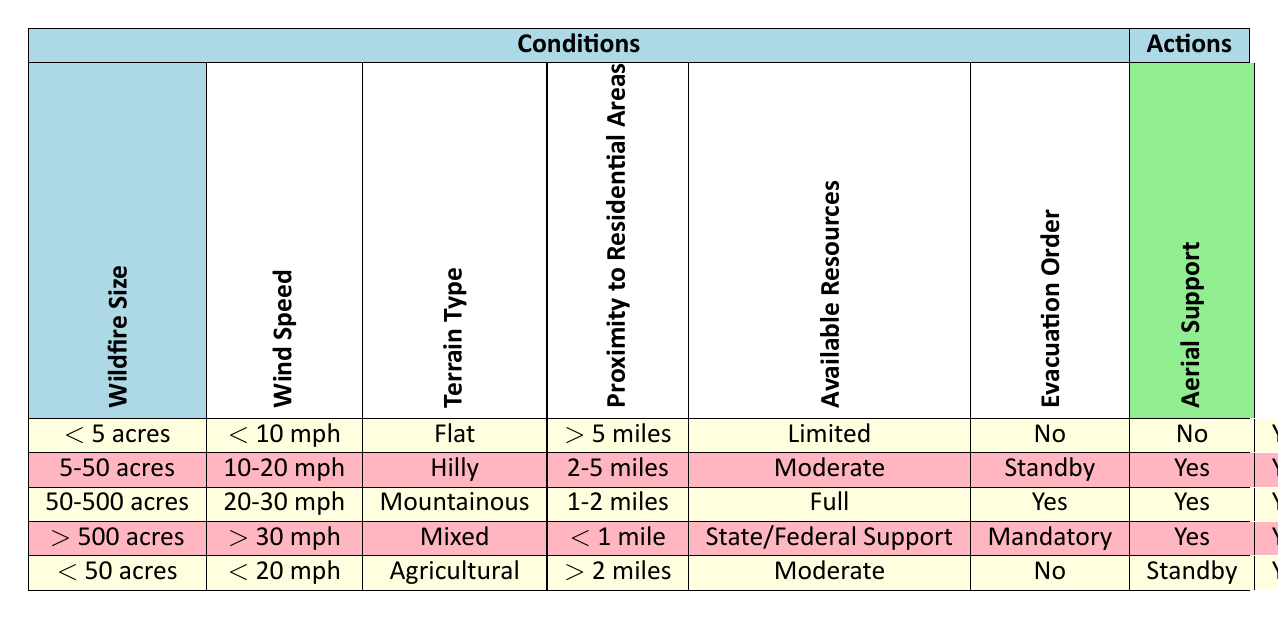What evacuation order is given for a wildfire larger than 500 acres with high wind speed? According to the table, for a wildfire greater than 500 acres with wind speed exceeding 30 mph, the evacuation order is "Mandatory." This is explicitly stated in the last row under the condition of wildfire size and wind speed.
Answer: Mandatory What is the action taken if the wildfire size is less than 5 acres and resources are limited? For a wildfire size of less than 5 acres with limited resources, the actions specified in the table are: Evacuation Order - No, Aerial Support - No, Firebreak Creation - Yes, Water Bombing - No, and Ground Crew Deployment - Yes.
Answer: Firebreak Creation and Ground Crew Deployment Is there Aerial Support for a wildfire between 5 and 50 acres on standby? Yes, there is aerial support confirmed for a wildfire of size between 5 to 50 acres with moderate resources; the table indicates that the aerial support action is marked as Yes.
Answer: Yes What actions would be taken for a wildfire that is hilly, with a size less than 50 acres and moderate resources? Analyzing the conditions for a wildfire that is hilly and less than 50 acres with moderate resources, we can refer to the last row that corresponds to these conditions. The actions specified are: Evacuation Order - No, Aerial Support - Standby, Firebreak Creation - Yes, Water Bombing - No, Ground Crew Deployment - Yes.
Answer: Aerial Support Standby and Firebreak Creation and Ground Crew Deployment For a mountainous wildfire between 50 to 500 acres, what is the Water Bombing status? For a wildfire in mountainous terrain that is between 50 to 500 acres size, according to the table, the water bombing status is Yes. This is clearly indicated in the relevant row where the conditions match.
Answer: Yes How many total actions are specified for a wildfire sized 5-50 acres with strong wind speed? Analyzing the row corresponding to a wildfire size of 5-50 acres with wind speed of 10-20 mph, we find the following actions: Evacuation Order - Standby, Aerial Support - Yes, Firebreak Creation - Yes, Water Bombing - Yes, and Ground Crew Deployment - Yes. This totals to 5 actions specified for this scenario.
Answer: 5 Is it correct that a wildfire larger than 500 acres with mixed terrain has no support for water bombing? According to the data in the table, for a wildfire greater than 500 acres in mixed terrain, the water bombing status is Yes, indicating that it does have support for water bombing, thus making the statement incorrect.
Answer: No What is the evacuation order for a fire in agricultural terrain under 50 acres, less than 20 mph wind speed, and moderate resources? From the table, the evacuation order for a wildfire in agricultural terrain that is less than 50 acres, with wind speed less than 20 mph and moderate resources, is marked as No, indicating that there is no evacuation order in this scenario.
Answer: No 